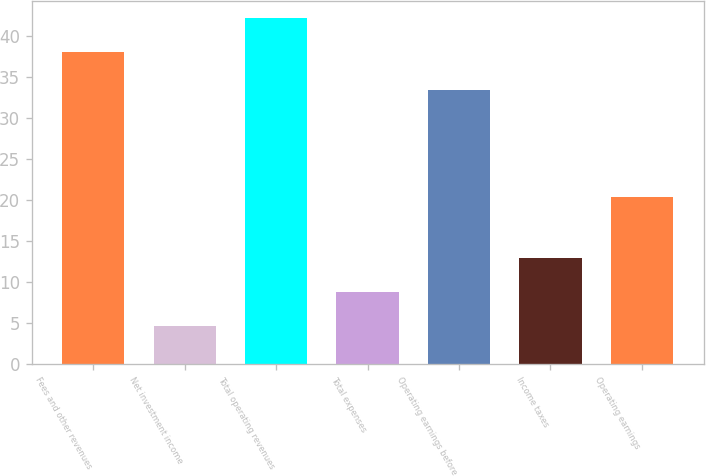Convert chart to OTSL. <chart><loc_0><loc_0><loc_500><loc_500><bar_chart><fcel>Fees and other revenues<fcel>Net investment income<fcel>Total operating revenues<fcel>Total expenses<fcel>Operating earnings before<fcel>Income taxes<fcel>Operating earnings<nl><fcel>38<fcel>4.56<fcel>42.16<fcel>8.72<fcel>33.4<fcel>12.88<fcel>20.3<nl></chart> 